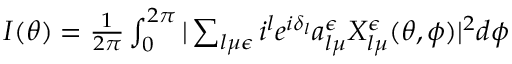<formula> <loc_0><loc_0><loc_500><loc_500>\begin{array} { r } { I ( \theta ) = \frac { 1 } { 2 \pi } \int _ { 0 } ^ { 2 \pi } | \sum _ { l \mu \epsilon } i ^ { l } e ^ { i \delta _ { l } } a _ { l \mu } ^ { \epsilon } X _ { l \mu } ^ { \epsilon } ( \theta , \phi ) | ^ { 2 } d \phi } \end{array}</formula> 